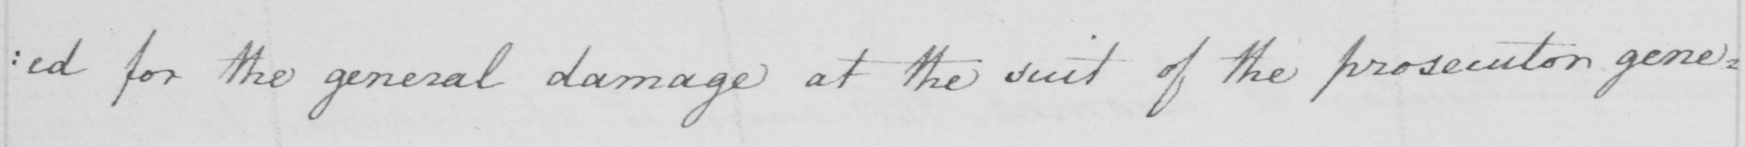Please provide the text content of this handwritten line. : ed for the general damage at the suit of the prosecutor gene : 